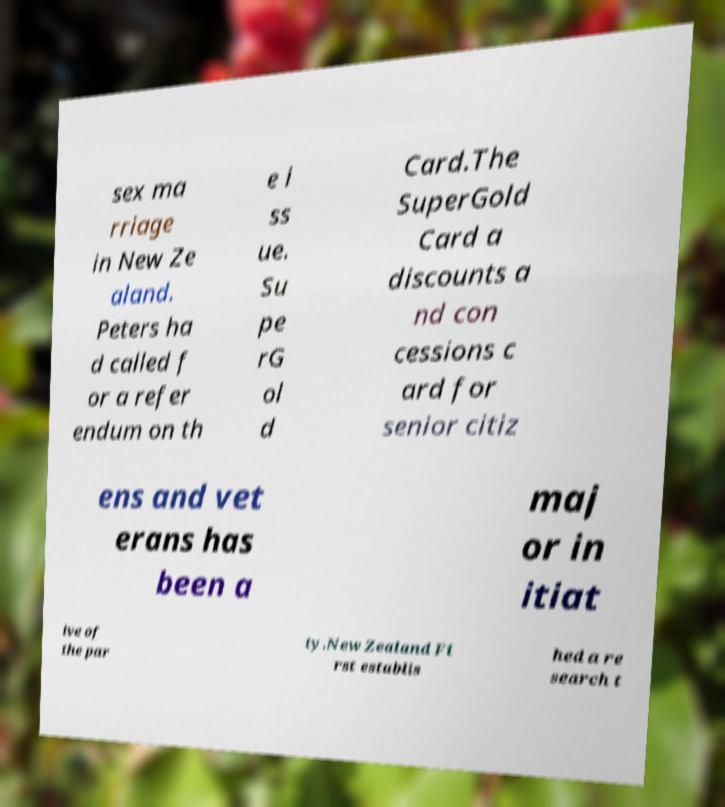Could you extract and type out the text from this image? sex ma rriage in New Ze aland. Peters ha d called f or a refer endum on th e i ss ue. Su pe rG ol d Card.The SuperGold Card a discounts a nd con cessions c ard for senior citiz ens and vet erans has been a maj or in itiat ive of the par ty.New Zealand Fi rst establis hed a re search t 